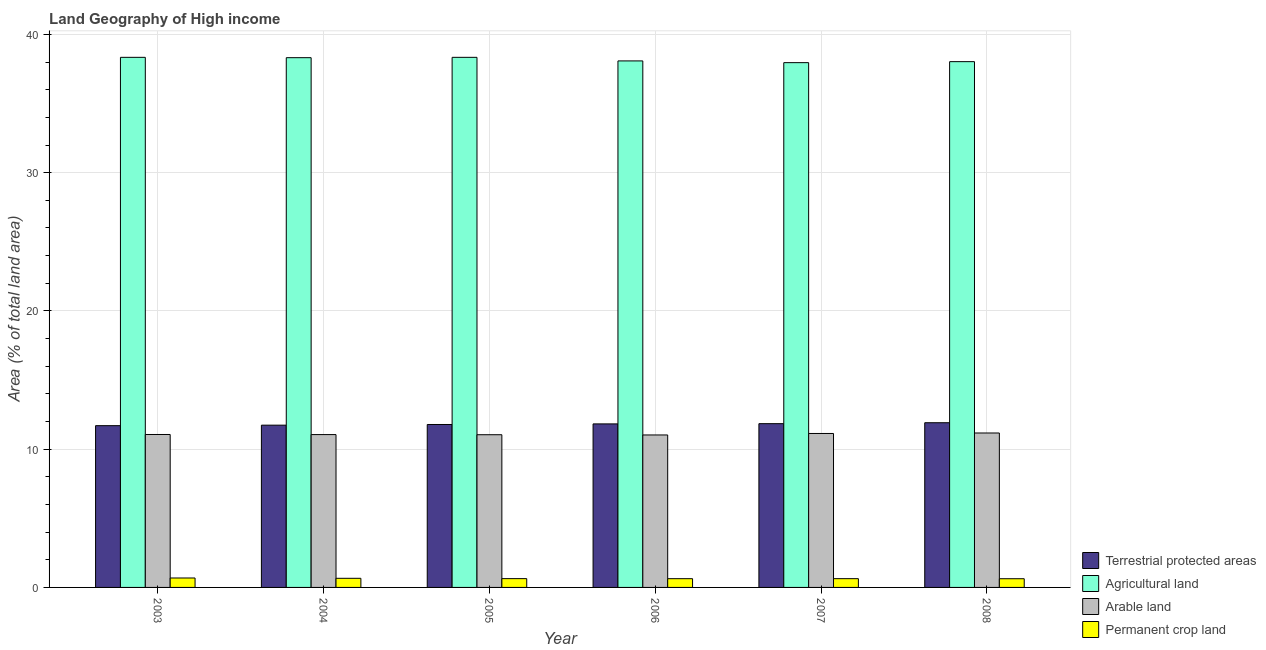How many different coloured bars are there?
Your response must be concise. 4. How many groups of bars are there?
Keep it short and to the point. 6. Are the number of bars per tick equal to the number of legend labels?
Give a very brief answer. Yes. Are the number of bars on each tick of the X-axis equal?
Offer a terse response. Yes. How many bars are there on the 2nd tick from the left?
Make the answer very short. 4. In how many cases, is the number of bars for a given year not equal to the number of legend labels?
Provide a succinct answer. 0. What is the percentage of land under terrestrial protection in 2004?
Give a very brief answer. 11.74. Across all years, what is the maximum percentage of area under agricultural land?
Keep it short and to the point. 38.34. Across all years, what is the minimum percentage of area under agricultural land?
Your response must be concise. 37.96. What is the total percentage of area under arable land in the graph?
Offer a very short reply. 66.5. What is the difference between the percentage of area under agricultural land in 2003 and that in 2004?
Provide a short and direct response. 0.02. What is the difference between the percentage of area under agricultural land in 2005 and the percentage of area under permanent crop land in 2007?
Make the answer very short. 0.38. What is the average percentage of area under agricultural land per year?
Ensure brevity in your answer.  38.18. What is the ratio of the percentage of area under permanent crop land in 2003 to that in 2004?
Provide a succinct answer. 1.03. What is the difference between the highest and the second highest percentage of area under agricultural land?
Make the answer very short. 0. What is the difference between the highest and the lowest percentage of area under arable land?
Provide a short and direct response. 0.14. In how many years, is the percentage of area under permanent crop land greater than the average percentage of area under permanent crop land taken over all years?
Provide a succinct answer. 2. Is the sum of the percentage of area under permanent crop land in 2004 and 2008 greater than the maximum percentage of area under arable land across all years?
Your response must be concise. Yes. Is it the case that in every year, the sum of the percentage of area under agricultural land and percentage of area under arable land is greater than the sum of percentage of area under permanent crop land and percentage of land under terrestrial protection?
Ensure brevity in your answer.  Yes. What does the 2nd bar from the left in 2004 represents?
Your answer should be very brief. Agricultural land. What does the 3rd bar from the right in 2004 represents?
Provide a short and direct response. Agricultural land. Is it the case that in every year, the sum of the percentage of land under terrestrial protection and percentage of area under agricultural land is greater than the percentage of area under arable land?
Offer a very short reply. Yes. How many bars are there?
Offer a terse response. 24. How many years are there in the graph?
Ensure brevity in your answer.  6. Are the values on the major ticks of Y-axis written in scientific E-notation?
Give a very brief answer. No. Does the graph contain any zero values?
Make the answer very short. No. Does the graph contain grids?
Your response must be concise. Yes. How many legend labels are there?
Provide a short and direct response. 4. What is the title of the graph?
Your answer should be compact. Land Geography of High income. Does "Trade" appear as one of the legend labels in the graph?
Give a very brief answer. No. What is the label or title of the X-axis?
Provide a succinct answer. Year. What is the label or title of the Y-axis?
Ensure brevity in your answer.  Area (% of total land area). What is the Area (% of total land area) in Terrestrial protected areas in 2003?
Keep it short and to the point. 11.7. What is the Area (% of total land area) of Agricultural land in 2003?
Provide a succinct answer. 38.34. What is the Area (% of total land area) of Arable land in 2003?
Offer a terse response. 11.06. What is the Area (% of total land area) in Permanent crop land in 2003?
Provide a succinct answer. 0.68. What is the Area (% of total land area) in Terrestrial protected areas in 2004?
Keep it short and to the point. 11.74. What is the Area (% of total land area) of Agricultural land in 2004?
Give a very brief answer. 38.32. What is the Area (% of total land area) of Arable land in 2004?
Provide a succinct answer. 11.06. What is the Area (% of total land area) of Permanent crop land in 2004?
Your answer should be compact. 0.66. What is the Area (% of total land area) in Terrestrial protected areas in 2005?
Keep it short and to the point. 11.79. What is the Area (% of total land area) of Agricultural land in 2005?
Offer a very short reply. 38.34. What is the Area (% of total land area) in Arable land in 2005?
Your response must be concise. 11.05. What is the Area (% of total land area) of Permanent crop land in 2005?
Your answer should be very brief. 0.64. What is the Area (% of total land area) in Terrestrial protected areas in 2006?
Make the answer very short. 11.83. What is the Area (% of total land area) of Agricultural land in 2006?
Make the answer very short. 38.09. What is the Area (% of total land area) in Arable land in 2006?
Your answer should be compact. 11.03. What is the Area (% of total land area) of Permanent crop land in 2006?
Your response must be concise. 0.63. What is the Area (% of total land area) of Terrestrial protected areas in 2007?
Your answer should be compact. 11.85. What is the Area (% of total land area) of Agricultural land in 2007?
Make the answer very short. 37.96. What is the Area (% of total land area) of Arable land in 2007?
Give a very brief answer. 11.14. What is the Area (% of total land area) of Permanent crop land in 2007?
Your answer should be very brief. 0.63. What is the Area (% of total land area) of Terrestrial protected areas in 2008?
Your answer should be compact. 11.91. What is the Area (% of total land area) of Agricultural land in 2008?
Provide a succinct answer. 38.03. What is the Area (% of total land area) in Arable land in 2008?
Your response must be concise. 11.17. What is the Area (% of total land area) in Permanent crop land in 2008?
Your answer should be compact. 0.63. Across all years, what is the maximum Area (% of total land area) of Terrestrial protected areas?
Provide a short and direct response. 11.91. Across all years, what is the maximum Area (% of total land area) of Agricultural land?
Your answer should be very brief. 38.34. Across all years, what is the maximum Area (% of total land area) of Arable land?
Provide a short and direct response. 11.17. Across all years, what is the maximum Area (% of total land area) in Permanent crop land?
Your answer should be compact. 0.68. Across all years, what is the minimum Area (% of total land area) of Terrestrial protected areas?
Give a very brief answer. 11.7. Across all years, what is the minimum Area (% of total land area) of Agricultural land?
Keep it short and to the point. 37.96. Across all years, what is the minimum Area (% of total land area) of Arable land?
Your answer should be compact. 11.03. Across all years, what is the minimum Area (% of total land area) of Permanent crop land?
Give a very brief answer. 0.63. What is the total Area (% of total land area) of Terrestrial protected areas in the graph?
Ensure brevity in your answer.  70.81. What is the total Area (% of total land area) of Agricultural land in the graph?
Provide a short and direct response. 229.09. What is the total Area (% of total land area) in Arable land in the graph?
Offer a terse response. 66.5. What is the total Area (% of total land area) in Permanent crop land in the graph?
Give a very brief answer. 3.87. What is the difference between the Area (% of total land area) in Terrestrial protected areas in 2003 and that in 2004?
Give a very brief answer. -0.04. What is the difference between the Area (% of total land area) of Agricultural land in 2003 and that in 2004?
Keep it short and to the point. 0.02. What is the difference between the Area (% of total land area) in Arable land in 2003 and that in 2004?
Keep it short and to the point. 0.01. What is the difference between the Area (% of total land area) of Permanent crop land in 2003 and that in 2004?
Make the answer very short. 0.02. What is the difference between the Area (% of total land area) in Terrestrial protected areas in 2003 and that in 2005?
Your response must be concise. -0.08. What is the difference between the Area (% of total land area) in Agricultural land in 2003 and that in 2005?
Ensure brevity in your answer.  -0. What is the difference between the Area (% of total land area) in Arable land in 2003 and that in 2005?
Your answer should be compact. 0.02. What is the difference between the Area (% of total land area) in Permanent crop land in 2003 and that in 2005?
Your answer should be very brief. 0.05. What is the difference between the Area (% of total land area) in Terrestrial protected areas in 2003 and that in 2006?
Offer a very short reply. -0.13. What is the difference between the Area (% of total land area) of Agricultural land in 2003 and that in 2006?
Your response must be concise. 0.26. What is the difference between the Area (% of total land area) in Arable land in 2003 and that in 2006?
Your answer should be very brief. 0.03. What is the difference between the Area (% of total land area) in Permanent crop land in 2003 and that in 2006?
Your answer should be compact. 0.05. What is the difference between the Area (% of total land area) of Terrestrial protected areas in 2003 and that in 2007?
Your answer should be very brief. -0.14. What is the difference between the Area (% of total land area) of Agricultural land in 2003 and that in 2007?
Ensure brevity in your answer.  0.38. What is the difference between the Area (% of total land area) in Arable land in 2003 and that in 2007?
Provide a succinct answer. -0.07. What is the difference between the Area (% of total land area) of Permanent crop land in 2003 and that in 2007?
Your answer should be compact. 0.05. What is the difference between the Area (% of total land area) in Terrestrial protected areas in 2003 and that in 2008?
Make the answer very short. -0.21. What is the difference between the Area (% of total land area) in Agricultural land in 2003 and that in 2008?
Your answer should be compact. 0.31. What is the difference between the Area (% of total land area) of Arable land in 2003 and that in 2008?
Provide a short and direct response. -0.11. What is the difference between the Area (% of total land area) of Permanent crop land in 2003 and that in 2008?
Ensure brevity in your answer.  0.05. What is the difference between the Area (% of total land area) in Terrestrial protected areas in 2004 and that in 2005?
Provide a short and direct response. -0.05. What is the difference between the Area (% of total land area) of Agricultural land in 2004 and that in 2005?
Provide a short and direct response. -0.03. What is the difference between the Area (% of total land area) of Arable land in 2004 and that in 2005?
Keep it short and to the point. 0.01. What is the difference between the Area (% of total land area) of Permanent crop land in 2004 and that in 2005?
Your answer should be compact. 0.02. What is the difference between the Area (% of total land area) in Terrestrial protected areas in 2004 and that in 2006?
Your response must be concise. -0.09. What is the difference between the Area (% of total land area) of Agricultural land in 2004 and that in 2006?
Provide a short and direct response. 0.23. What is the difference between the Area (% of total land area) in Arable land in 2004 and that in 2006?
Provide a short and direct response. 0.03. What is the difference between the Area (% of total land area) in Permanent crop land in 2004 and that in 2006?
Provide a succinct answer. 0.03. What is the difference between the Area (% of total land area) of Terrestrial protected areas in 2004 and that in 2007?
Offer a very short reply. -0.11. What is the difference between the Area (% of total land area) of Agricultural land in 2004 and that in 2007?
Keep it short and to the point. 0.36. What is the difference between the Area (% of total land area) of Arable land in 2004 and that in 2007?
Offer a terse response. -0.08. What is the difference between the Area (% of total land area) in Permanent crop land in 2004 and that in 2007?
Keep it short and to the point. 0.03. What is the difference between the Area (% of total land area) of Terrestrial protected areas in 2004 and that in 2008?
Provide a short and direct response. -0.18. What is the difference between the Area (% of total land area) in Agricultural land in 2004 and that in 2008?
Make the answer very short. 0.29. What is the difference between the Area (% of total land area) of Arable land in 2004 and that in 2008?
Ensure brevity in your answer.  -0.12. What is the difference between the Area (% of total land area) of Permanent crop land in 2004 and that in 2008?
Your answer should be very brief. 0.03. What is the difference between the Area (% of total land area) of Terrestrial protected areas in 2005 and that in 2006?
Make the answer very short. -0.04. What is the difference between the Area (% of total land area) in Agricultural land in 2005 and that in 2006?
Ensure brevity in your answer.  0.26. What is the difference between the Area (% of total land area) of Arable land in 2005 and that in 2006?
Provide a short and direct response. 0.02. What is the difference between the Area (% of total land area) in Permanent crop land in 2005 and that in 2006?
Provide a short and direct response. 0. What is the difference between the Area (% of total land area) in Terrestrial protected areas in 2005 and that in 2007?
Offer a very short reply. -0.06. What is the difference between the Area (% of total land area) of Agricultural land in 2005 and that in 2007?
Offer a very short reply. 0.38. What is the difference between the Area (% of total land area) of Arable land in 2005 and that in 2007?
Offer a terse response. -0.09. What is the difference between the Area (% of total land area) of Permanent crop land in 2005 and that in 2007?
Provide a succinct answer. 0. What is the difference between the Area (% of total land area) of Terrestrial protected areas in 2005 and that in 2008?
Your answer should be very brief. -0.13. What is the difference between the Area (% of total land area) in Agricultural land in 2005 and that in 2008?
Ensure brevity in your answer.  0.31. What is the difference between the Area (% of total land area) in Arable land in 2005 and that in 2008?
Keep it short and to the point. -0.13. What is the difference between the Area (% of total land area) in Permanent crop land in 2005 and that in 2008?
Your answer should be very brief. 0.01. What is the difference between the Area (% of total land area) in Terrestrial protected areas in 2006 and that in 2007?
Give a very brief answer. -0.02. What is the difference between the Area (% of total land area) of Agricultural land in 2006 and that in 2007?
Ensure brevity in your answer.  0.13. What is the difference between the Area (% of total land area) in Arable land in 2006 and that in 2007?
Make the answer very short. -0.11. What is the difference between the Area (% of total land area) of Permanent crop land in 2006 and that in 2007?
Provide a succinct answer. -0. What is the difference between the Area (% of total land area) in Terrestrial protected areas in 2006 and that in 2008?
Give a very brief answer. -0.08. What is the difference between the Area (% of total land area) in Agricultural land in 2006 and that in 2008?
Ensure brevity in your answer.  0.05. What is the difference between the Area (% of total land area) in Arable land in 2006 and that in 2008?
Provide a succinct answer. -0.14. What is the difference between the Area (% of total land area) of Permanent crop land in 2006 and that in 2008?
Make the answer very short. 0. What is the difference between the Area (% of total land area) of Terrestrial protected areas in 2007 and that in 2008?
Your response must be concise. -0.07. What is the difference between the Area (% of total land area) in Agricultural land in 2007 and that in 2008?
Offer a very short reply. -0.07. What is the difference between the Area (% of total land area) in Arable land in 2007 and that in 2008?
Keep it short and to the point. -0.04. What is the difference between the Area (% of total land area) in Permanent crop land in 2007 and that in 2008?
Make the answer very short. 0. What is the difference between the Area (% of total land area) in Terrestrial protected areas in 2003 and the Area (% of total land area) in Agricultural land in 2004?
Make the answer very short. -26.62. What is the difference between the Area (% of total land area) of Terrestrial protected areas in 2003 and the Area (% of total land area) of Arable land in 2004?
Your answer should be very brief. 0.65. What is the difference between the Area (% of total land area) in Terrestrial protected areas in 2003 and the Area (% of total land area) in Permanent crop land in 2004?
Give a very brief answer. 11.04. What is the difference between the Area (% of total land area) of Agricultural land in 2003 and the Area (% of total land area) of Arable land in 2004?
Make the answer very short. 27.29. What is the difference between the Area (% of total land area) of Agricultural land in 2003 and the Area (% of total land area) of Permanent crop land in 2004?
Offer a very short reply. 37.68. What is the difference between the Area (% of total land area) in Arable land in 2003 and the Area (% of total land area) in Permanent crop land in 2004?
Your response must be concise. 10.4. What is the difference between the Area (% of total land area) of Terrestrial protected areas in 2003 and the Area (% of total land area) of Agricultural land in 2005?
Ensure brevity in your answer.  -26.64. What is the difference between the Area (% of total land area) of Terrestrial protected areas in 2003 and the Area (% of total land area) of Arable land in 2005?
Offer a very short reply. 0.66. What is the difference between the Area (% of total land area) in Terrestrial protected areas in 2003 and the Area (% of total land area) in Permanent crop land in 2005?
Offer a very short reply. 11.06. What is the difference between the Area (% of total land area) in Agricultural land in 2003 and the Area (% of total land area) in Arable land in 2005?
Offer a terse response. 27.3. What is the difference between the Area (% of total land area) in Agricultural land in 2003 and the Area (% of total land area) in Permanent crop land in 2005?
Your response must be concise. 37.71. What is the difference between the Area (% of total land area) of Arable land in 2003 and the Area (% of total land area) of Permanent crop land in 2005?
Make the answer very short. 10.43. What is the difference between the Area (% of total land area) of Terrestrial protected areas in 2003 and the Area (% of total land area) of Agricultural land in 2006?
Keep it short and to the point. -26.38. What is the difference between the Area (% of total land area) of Terrestrial protected areas in 2003 and the Area (% of total land area) of Arable land in 2006?
Your answer should be compact. 0.67. What is the difference between the Area (% of total land area) in Terrestrial protected areas in 2003 and the Area (% of total land area) in Permanent crop land in 2006?
Offer a terse response. 11.07. What is the difference between the Area (% of total land area) in Agricultural land in 2003 and the Area (% of total land area) in Arable land in 2006?
Offer a terse response. 27.32. What is the difference between the Area (% of total land area) in Agricultural land in 2003 and the Area (% of total land area) in Permanent crop land in 2006?
Ensure brevity in your answer.  37.71. What is the difference between the Area (% of total land area) of Arable land in 2003 and the Area (% of total land area) of Permanent crop land in 2006?
Offer a very short reply. 10.43. What is the difference between the Area (% of total land area) in Terrestrial protected areas in 2003 and the Area (% of total land area) in Agricultural land in 2007?
Ensure brevity in your answer.  -26.26. What is the difference between the Area (% of total land area) of Terrestrial protected areas in 2003 and the Area (% of total land area) of Arable land in 2007?
Your answer should be very brief. 0.57. What is the difference between the Area (% of total land area) of Terrestrial protected areas in 2003 and the Area (% of total land area) of Permanent crop land in 2007?
Keep it short and to the point. 11.07. What is the difference between the Area (% of total land area) in Agricultural land in 2003 and the Area (% of total land area) in Arable land in 2007?
Ensure brevity in your answer.  27.21. What is the difference between the Area (% of total land area) in Agricultural land in 2003 and the Area (% of total land area) in Permanent crop land in 2007?
Offer a very short reply. 37.71. What is the difference between the Area (% of total land area) of Arable land in 2003 and the Area (% of total land area) of Permanent crop land in 2007?
Your response must be concise. 10.43. What is the difference between the Area (% of total land area) of Terrestrial protected areas in 2003 and the Area (% of total land area) of Agricultural land in 2008?
Keep it short and to the point. -26.33. What is the difference between the Area (% of total land area) in Terrestrial protected areas in 2003 and the Area (% of total land area) in Arable land in 2008?
Keep it short and to the point. 0.53. What is the difference between the Area (% of total land area) of Terrestrial protected areas in 2003 and the Area (% of total land area) of Permanent crop land in 2008?
Ensure brevity in your answer.  11.07. What is the difference between the Area (% of total land area) in Agricultural land in 2003 and the Area (% of total land area) in Arable land in 2008?
Give a very brief answer. 27.17. What is the difference between the Area (% of total land area) in Agricultural land in 2003 and the Area (% of total land area) in Permanent crop land in 2008?
Your answer should be compact. 37.71. What is the difference between the Area (% of total land area) in Arable land in 2003 and the Area (% of total land area) in Permanent crop land in 2008?
Offer a very short reply. 10.43. What is the difference between the Area (% of total land area) of Terrestrial protected areas in 2004 and the Area (% of total land area) of Agricultural land in 2005?
Keep it short and to the point. -26.61. What is the difference between the Area (% of total land area) in Terrestrial protected areas in 2004 and the Area (% of total land area) in Arable land in 2005?
Give a very brief answer. 0.69. What is the difference between the Area (% of total land area) in Terrestrial protected areas in 2004 and the Area (% of total land area) in Permanent crop land in 2005?
Give a very brief answer. 11.1. What is the difference between the Area (% of total land area) of Agricultural land in 2004 and the Area (% of total land area) of Arable land in 2005?
Ensure brevity in your answer.  27.27. What is the difference between the Area (% of total land area) in Agricultural land in 2004 and the Area (% of total land area) in Permanent crop land in 2005?
Ensure brevity in your answer.  37.68. What is the difference between the Area (% of total land area) of Arable land in 2004 and the Area (% of total land area) of Permanent crop land in 2005?
Your answer should be compact. 10.42. What is the difference between the Area (% of total land area) in Terrestrial protected areas in 2004 and the Area (% of total land area) in Agricultural land in 2006?
Provide a short and direct response. -26.35. What is the difference between the Area (% of total land area) in Terrestrial protected areas in 2004 and the Area (% of total land area) in Arable land in 2006?
Your answer should be very brief. 0.71. What is the difference between the Area (% of total land area) in Terrestrial protected areas in 2004 and the Area (% of total land area) in Permanent crop land in 2006?
Ensure brevity in your answer.  11.1. What is the difference between the Area (% of total land area) of Agricultural land in 2004 and the Area (% of total land area) of Arable land in 2006?
Keep it short and to the point. 27.29. What is the difference between the Area (% of total land area) in Agricultural land in 2004 and the Area (% of total land area) in Permanent crop land in 2006?
Your answer should be very brief. 37.69. What is the difference between the Area (% of total land area) in Arable land in 2004 and the Area (% of total land area) in Permanent crop land in 2006?
Give a very brief answer. 10.42. What is the difference between the Area (% of total land area) in Terrestrial protected areas in 2004 and the Area (% of total land area) in Agricultural land in 2007?
Provide a succinct answer. -26.22. What is the difference between the Area (% of total land area) in Terrestrial protected areas in 2004 and the Area (% of total land area) in Arable land in 2007?
Ensure brevity in your answer.  0.6. What is the difference between the Area (% of total land area) of Terrestrial protected areas in 2004 and the Area (% of total land area) of Permanent crop land in 2007?
Provide a succinct answer. 11.1. What is the difference between the Area (% of total land area) of Agricultural land in 2004 and the Area (% of total land area) of Arable land in 2007?
Offer a terse response. 27.18. What is the difference between the Area (% of total land area) in Agricultural land in 2004 and the Area (% of total land area) in Permanent crop land in 2007?
Keep it short and to the point. 37.69. What is the difference between the Area (% of total land area) in Arable land in 2004 and the Area (% of total land area) in Permanent crop land in 2007?
Your response must be concise. 10.42. What is the difference between the Area (% of total land area) in Terrestrial protected areas in 2004 and the Area (% of total land area) in Agricultural land in 2008?
Offer a terse response. -26.3. What is the difference between the Area (% of total land area) in Terrestrial protected areas in 2004 and the Area (% of total land area) in Arable land in 2008?
Offer a very short reply. 0.57. What is the difference between the Area (% of total land area) in Terrestrial protected areas in 2004 and the Area (% of total land area) in Permanent crop land in 2008?
Give a very brief answer. 11.11. What is the difference between the Area (% of total land area) in Agricultural land in 2004 and the Area (% of total land area) in Arable land in 2008?
Give a very brief answer. 27.15. What is the difference between the Area (% of total land area) of Agricultural land in 2004 and the Area (% of total land area) of Permanent crop land in 2008?
Offer a very short reply. 37.69. What is the difference between the Area (% of total land area) in Arable land in 2004 and the Area (% of total land area) in Permanent crop land in 2008?
Make the answer very short. 10.43. What is the difference between the Area (% of total land area) of Terrestrial protected areas in 2005 and the Area (% of total land area) of Agricultural land in 2006?
Provide a succinct answer. -26.3. What is the difference between the Area (% of total land area) of Terrestrial protected areas in 2005 and the Area (% of total land area) of Arable land in 2006?
Your answer should be compact. 0.76. What is the difference between the Area (% of total land area) of Terrestrial protected areas in 2005 and the Area (% of total land area) of Permanent crop land in 2006?
Your response must be concise. 11.15. What is the difference between the Area (% of total land area) of Agricultural land in 2005 and the Area (% of total land area) of Arable land in 2006?
Offer a very short reply. 27.32. What is the difference between the Area (% of total land area) in Agricultural land in 2005 and the Area (% of total land area) in Permanent crop land in 2006?
Offer a terse response. 37.71. What is the difference between the Area (% of total land area) in Arable land in 2005 and the Area (% of total land area) in Permanent crop land in 2006?
Your answer should be compact. 10.41. What is the difference between the Area (% of total land area) of Terrestrial protected areas in 2005 and the Area (% of total land area) of Agricultural land in 2007?
Offer a very short reply. -26.17. What is the difference between the Area (% of total land area) of Terrestrial protected areas in 2005 and the Area (% of total land area) of Arable land in 2007?
Your answer should be compact. 0.65. What is the difference between the Area (% of total land area) in Terrestrial protected areas in 2005 and the Area (% of total land area) in Permanent crop land in 2007?
Make the answer very short. 11.15. What is the difference between the Area (% of total land area) of Agricultural land in 2005 and the Area (% of total land area) of Arable land in 2007?
Give a very brief answer. 27.21. What is the difference between the Area (% of total land area) of Agricultural land in 2005 and the Area (% of total land area) of Permanent crop land in 2007?
Keep it short and to the point. 37.71. What is the difference between the Area (% of total land area) in Arable land in 2005 and the Area (% of total land area) in Permanent crop land in 2007?
Give a very brief answer. 10.41. What is the difference between the Area (% of total land area) in Terrestrial protected areas in 2005 and the Area (% of total land area) in Agricultural land in 2008?
Provide a short and direct response. -26.25. What is the difference between the Area (% of total land area) in Terrestrial protected areas in 2005 and the Area (% of total land area) in Arable land in 2008?
Offer a terse response. 0.61. What is the difference between the Area (% of total land area) of Terrestrial protected areas in 2005 and the Area (% of total land area) of Permanent crop land in 2008?
Provide a succinct answer. 11.16. What is the difference between the Area (% of total land area) in Agricultural land in 2005 and the Area (% of total land area) in Arable land in 2008?
Ensure brevity in your answer.  27.17. What is the difference between the Area (% of total land area) of Agricultural land in 2005 and the Area (% of total land area) of Permanent crop land in 2008?
Make the answer very short. 37.72. What is the difference between the Area (% of total land area) of Arable land in 2005 and the Area (% of total land area) of Permanent crop land in 2008?
Make the answer very short. 10.42. What is the difference between the Area (% of total land area) of Terrestrial protected areas in 2006 and the Area (% of total land area) of Agricultural land in 2007?
Keep it short and to the point. -26.13. What is the difference between the Area (% of total land area) of Terrestrial protected areas in 2006 and the Area (% of total land area) of Arable land in 2007?
Ensure brevity in your answer.  0.69. What is the difference between the Area (% of total land area) in Terrestrial protected areas in 2006 and the Area (% of total land area) in Permanent crop land in 2007?
Offer a very short reply. 11.2. What is the difference between the Area (% of total land area) in Agricultural land in 2006 and the Area (% of total land area) in Arable land in 2007?
Keep it short and to the point. 26.95. What is the difference between the Area (% of total land area) of Agricultural land in 2006 and the Area (% of total land area) of Permanent crop land in 2007?
Give a very brief answer. 37.45. What is the difference between the Area (% of total land area) in Arable land in 2006 and the Area (% of total land area) in Permanent crop land in 2007?
Offer a very short reply. 10.39. What is the difference between the Area (% of total land area) in Terrestrial protected areas in 2006 and the Area (% of total land area) in Agricultural land in 2008?
Give a very brief answer. -26.2. What is the difference between the Area (% of total land area) in Terrestrial protected areas in 2006 and the Area (% of total land area) in Arable land in 2008?
Your answer should be very brief. 0.66. What is the difference between the Area (% of total land area) of Terrestrial protected areas in 2006 and the Area (% of total land area) of Permanent crop land in 2008?
Offer a terse response. 11.2. What is the difference between the Area (% of total land area) of Agricultural land in 2006 and the Area (% of total land area) of Arable land in 2008?
Provide a succinct answer. 26.91. What is the difference between the Area (% of total land area) of Agricultural land in 2006 and the Area (% of total land area) of Permanent crop land in 2008?
Keep it short and to the point. 37.46. What is the difference between the Area (% of total land area) of Arable land in 2006 and the Area (% of total land area) of Permanent crop land in 2008?
Your response must be concise. 10.4. What is the difference between the Area (% of total land area) in Terrestrial protected areas in 2007 and the Area (% of total land area) in Agricultural land in 2008?
Provide a succinct answer. -26.19. What is the difference between the Area (% of total land area) of Terrestrial protected areas in 2007 and the Area (% of total land area) of Arable land in 2008?
Provide a short and direct response. 0.67. What is the difference between the Area (% of total land area) in Terrestrial protected areas in 2007 and the Area (% of total land area) in Permanent crop land in 2008?
Provide a short and direct response. 11.22. What is the difference between the Area (% of total land area) in Agricultural land in 2007 and the Area (% of total land area) in Arable land in 2008?
Provide a succinct answer. 26.79. What is the difference between the Area (% of total land area) of Agricultural land in 2007 and the Area (% of total land area) of Permanent crop land in 2008?
Offer a terse response. 37.33. What is the difference between the Area (% of total land area) of Arable land in 2007 and the Area (% of total land area) of Permanent crop land in 2008?
Ensure brevity in your answer.  10.51. What is the average Area (% of total land area) of Terrestrial protected areas per year?
Provide a succinct answer. 11.8. What is the average Area (% of total land area) in Agricultural land per year?
Provide a short and direct response. 38.18. What is the average Area (% of total land area) in Arable land per year?
Provide a short and direct response. 11.08. What is the average Area (% of total land area) in Permanent crop land per year?
Give a very brief answer. 0.65. In the year 2003, what is the difference between the Area (% of total land area) of Terrestrial protected areas and Area (% of total land area) of Agricultural land?
Provide a short and direct response. -26.64. In the year 2003, what is the difference between the Area (% of total land area) of Terrestrial protected areas and Area (% of total land area) of Arable land?
Provide a short and direct response. 0.64. In the year 2003, what is the difference between the Area (% of total land area) of Terrestrial protected areas and Area (% of total land area) of Permanent crop land?
Your answer should be compact. 11.02. In the year 2003, what is the difference between the Area (% of total land area) in Agricultural land and Area (% of total land area) in Arable land?
Offer a terse response. 27.28. In the year 2003, what is the difference between the Area (% of total land area) in Agricultural land and Area (% of total land area) in Permanent crop land?
Your response must be concise. 37.66. In the year 2003, what is the difference between the Area (% of total land area) of Arable land and Area (% of total land area) of Permanent crop land?
Give a very brief answer. 10.38. In the year 2004, what is the difference between the Area (% of total land area) of Terrestrial protected areas and Area (% of total land area) of Agricultural land?
Offer a very short reply. -26.58. In the year 2004, what is the difference between the Area (% of total land area) in Terrestrial protected areas and Area (% of total land area) in Arable land?
Your answer should be compact. 0.68. In the year 2004, what is the difference between the Area (% of total land area) of Terrestrial protected areas and Area (% of total land area) of Permanent crop land?
Provide a succinct answer. 11.08. In the year 2004, what is the difference between the Area (% of total land area) of Agricultural land and Area (% of total land area) of Arable land?
Your answer should be compact. 27.26. In the year 2004, what is the difference between the Area (% of total land area) in Agricultural land and Area (% of total land area) in Permanent crop land?
Offer a very short reply. 37.66. In the year 2004, what is the difference between the Area (% of total land area) of Arable land and Area (% of total land area) of Permanent crop land?
Give a very brief answer. 10.4. In the year 2005, what is the difference between the Area (% of total land area) in Terrestrial protected areas and Area (% of total land area) in Agricultural land?
Ensure brevity in your answer.  -26.56. In the year 2005, what is the difference between the Area (% of total land area) in Terrestrial protected areas and Area (% of total land area) in Arable land?
Provide a short and direct response. 0.74. In the year 2005, what is the difference between the Area (% of total land area) in Terrestrial protected areas and Area (% of total land area) in Permanent crop land?
Ensure brevity in your answer.  11.15. In the year 2005, what is the difference between the Area (% of total land area) in Agricultural land and Area (% of total land area) in Arable land?
Make the answer very short. 27.3. In the year 2005, what is the difference between the Area (% of total land area) of Agricultural land and Area (% of total land area) of Permanent crop land?
Ensure brevity in your answer.  37.71. In the year 2005, what is the difference between the Area (% of total land area) in Arable land and Area (% of total land area) in Permanent crop land?
Keep it short and to the point. 10.41. In the year 2006, what is the difference between the Area (% of total land area) in Terrestrial protected areas and Area (% of total land area) in Agricultural land?
Ensure brevity in your answer.  -26.26. In the year 2006, what is the difference between the Area (% of total land area) in Terrestrial protected areas and Area (% of total land area) in Arable land?
Make the answer very short. 0.8. In the year 2006, what is the difference between the Area (% of total land area) of Terrestrial protected areas and Area (% of total land area) of Permanent crop land?
Your answer should be very brief. 11.2. In the year 2006, what is the difference between the Area (% of total land area) in Agricultural land and Area (% of total land area) in Arable land?
Provide a succinct answer. 27.06. In the year 2006, what is the difference between the Area (% of total land area) of Agricultural land and Area (% of total land area) of Permanent crop land?
Your answer should be very brief. 37.45. In the year 2006, what is the difference between the Area (% of total land area) in Arable land and Area (% of total land area) in Permanent crop land?
Offer a very short reply. 10.4. In the year 2007, what is the difference between the Area (% of total land area) of Terrestrial protected areas and Area (% of total land area) of Agricultural land?
Keep it short and to the point. -26.11. In the year 2007, what is the difference between the Area (% of total land area) in Terrestrial protected areas and Area (% of total land area) in Arable land?
Your answer should be compact. 0.71. In the year 2007, what is the difference between the Area (% of total land area) of Terrestrial protected areas and Area (% of total land area) of Permanent crop land?
Your answer should be compact. 11.21. In the year 2007, what is the difference between the Area (% of total land area) in Agricultural land and Area (% of total land area) in Arable land?
Offer a very short reply. 26.82. In the year 2007, what is the difference between the Area (% of total land area) of Agricultural land and Area (% of total land area) of Permanent crop land?
Your response must be concise. 37.33. In the year 2007, what is the difference between the Area (% of total land area) in Arable land and Area (% of total land area) in Permanent crop land?
Give a very brief answer. 10.5. In the year 2008, what is the difference between the Area (% of total land area) in Terrestrial protected areas and Area (% of total land area) in Agricultural land?
Give a very brief answer. -26.12. In the year 2008, what is the difference between the Area (% of total land area) in Terrestrial protected areas and Area (% of total land area) in Arable land?
Provide a short and direct response. 0.74. In the year 2008, what is the difference between the Area (% of total land area) in Terrestrial protected areas and Area (% of total land area) in Permanent crop land?
Make the answer very short. 11.28. In the year 2008, what is the difference between the Area (% of total land area) of Agricultural land and Area (% of total land area) of Arable land?
Provide a succinct answer. 26.86. In the year 2008, what is the difference between the Area (% of total land area) of Agricultural land and Area (% of total land area) of Permanent crop land?
Your answer should be compact. 37.4. In the year 2008, what is the difference between the Area (% of total land area) of Arable land and Area (% of total land area) of Permanent crop land?
Your response must be concise. 10.54. What is the ratio of the Area (% of total land area) of Terrestrial protected areas in 2003 to that in 2004?
Your response must be concise. 1. What is the ratio of the Area (% of total land area) of Permanent crop land in 2003 to that in 2004?
Your response must be concise. 1.03. What is the ratio of the Area (% of total land area) in Permanent crop land in 2003 to that in 2005?
Make the answer very short. 1.07. What is the ratio of the Area (% of total land area) in Terrestrial protected areas in 2003 to that in 2006?
Offer a terse response. 0.99. What is the ratio of the Area (% of total land area) of Agricultural land in 2003 to that in 2006?
Offer a very short reply. 1.01. What is the ratio of the Area (% of total land area) of Arable land in 2003 to that in 2006?
Give a very brief answer. 1. What is the ratio of the Area (% of total land area) in Permanent crop land in 2003 to that in 2006?
Offer a very short reply. 1.08. What is the ratio of the Area (% of total land area) of Permanent crop land in 2003 to that in 2007?
Offer a terse response. 1.08. What is the ratio of the Area (% of total land area) of Terrestrial protected areas in 2003 to that in 2008?
Provide a short and direct response. 0.98. What is the ratio of the Area (% of total land area) in Agricultural land in 2003 to that in 2008?
Offer a terse response. 1.01. What is the ratio of the Area (% of total land area) in Arable land in 2003 to that in 2008?
Give a very brief answer. 0.99. What is the ratio of the Area (% of total land area) of Permanent crop land in 2003 to that in 2008?
Provide a short and direct response. 1.08. What is the ratio of the Area (% of total land area) of Agricultural land in 2004 to that in 2005?
Provide a short and direct response. 1. What is the ratio of the Area (% of total land area) of Arable land in 2004 to that in 2005?
Offer a terse response. 1. What is the ratio of the Area (% of total land area) of Permanent crop land in 2004 to that in 2005?
Make the answer very short. 1.04. What is the ratio of the Area (% of total land area) of Terrestrial protected areas in 2004 to that in 2006?
Your response must be concise. 0.99. What is the ratio of the Area (% of total land area) of Permanent crop land in 2004 to that in 2006?
Make the answer very short. 1.04. What is the ratio of the Area (% of total land area) of Agricultural land in 2004 to that in 2007?
Give a very brief answer. 1.01. What is the ratio of the Area (% of total land area) in Arable land in 2004 to that in 2007?
Your answer should be compact. 0.99. What is the ratio of the Area (% of total land area) in Permanent crop land in 2004 to that in 2007?
Offer a terse response. 1.04. What is the ratio of the Area (% of total land area) in Terrestrial protected areas in 2004 to that in 2008?
Make the answer very short. 0.99. What is the ratio of the Area (% of total land area) in Agricultural land in 2004 to that in 2008?
Your answer should be compact. 1.01. What is the ratio of the Area (% of total land area) in Permanent crop land in 2004 to that in 2008?
Make the answer very short. 1.05. What is the ratio of the Area (% of total land area) in Agricultural land in 2005 to that in 2006?
Offer a terse response. 1.01. What is the ratio of the Area (% of total land area) of Permanent crop land in 2005 to that in 2006?
Give a very brief answer. 1.01. What is the ratio of the Area (% of total land area) of Agricultural land in 2005 to that in 2007?
Provide a short and direct response. 1.01. What is the ratio of the Area (% of total land area) in Terrestrial protected areas in 2005 to that in 2008?
Make the answer very short. 0.99. What is the ratio of the Area (% of total land area) in Agricultural land in 2005 to that in 2008?
Offer a very short reply. 1.01. What is the ratio of the Area (% of total land area) of Terrestrial protected areas in 2006 to that in 2007?
Your response must be concise. 1. What is the ratio of the Area (% of total land area) in Arable land in 2006 to that in 2007?
Your answer should be very brief. 0.99. What is the ratio of the Area (% of total land area) in Permanent crop land in 2006 to that in 2007?
Provide a short and direct response. 1. What is the ratio of the Area (% of total land area) in Arable land in 2006 to that in 2008?
Offer a terse response. 0.99. What is the ratio of the Area (% of total land area) of Terrestrial protected areas in 2007 to that in 2008?
Provide a short and direct response. 0.99. What is the ratio of the Area (% of total land area) in Agricultural land in 2007 to that in 2008?
Your response must be concise. 1. What is the ratio of the Area (% of total land area) in Permanent crop land in 2007 to that in 2008?
Offer a very short reply. 1.01. What is the difference between the highest and the second highest Area (% of total land area) of Terrestrial protected areas?
Your answer should be compact. 0.07. What is the difference between the highest and the second highest Area (% of total land area) in Agricultural land?
Your response must be concise. 0. What is the difference between the highest and the second highest Area (% of total land area) in Arable land?
Provide a short and direct response. 0.04. What is the difference between the highest and the second highest Area (% of total land area) in Permanent crop land?
Your response must be concise. 0.02. What is the difference between the highest and the lowest Area (% of total land area) of Terrestrial protected areas?
Offer a very short reply. 0.21. What is the difference between the highest and the lowest Area (% of total land area) of Agricultural land?
Your answer should be compact. 0.38. What is the difference between the highest and the lowest Area (% of total land area) of Arable land?
Ensure brevity in your answer.  0.14. What is the difference between the highest and the lowest Area (% of total land area) in Permanent crop land?
Ensure brevity in your answer.  0.05. 